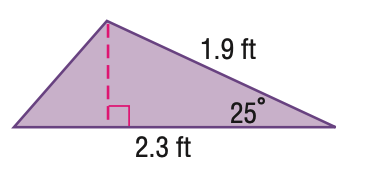Answer the mathemtical geometry problem and directly provide the correct option letter.
Question: Find the area of the triangle. Round to the nearest hundredth.
Choices: A: 0.92 B: 0.99 C: 1.02 D: 1.98 A 